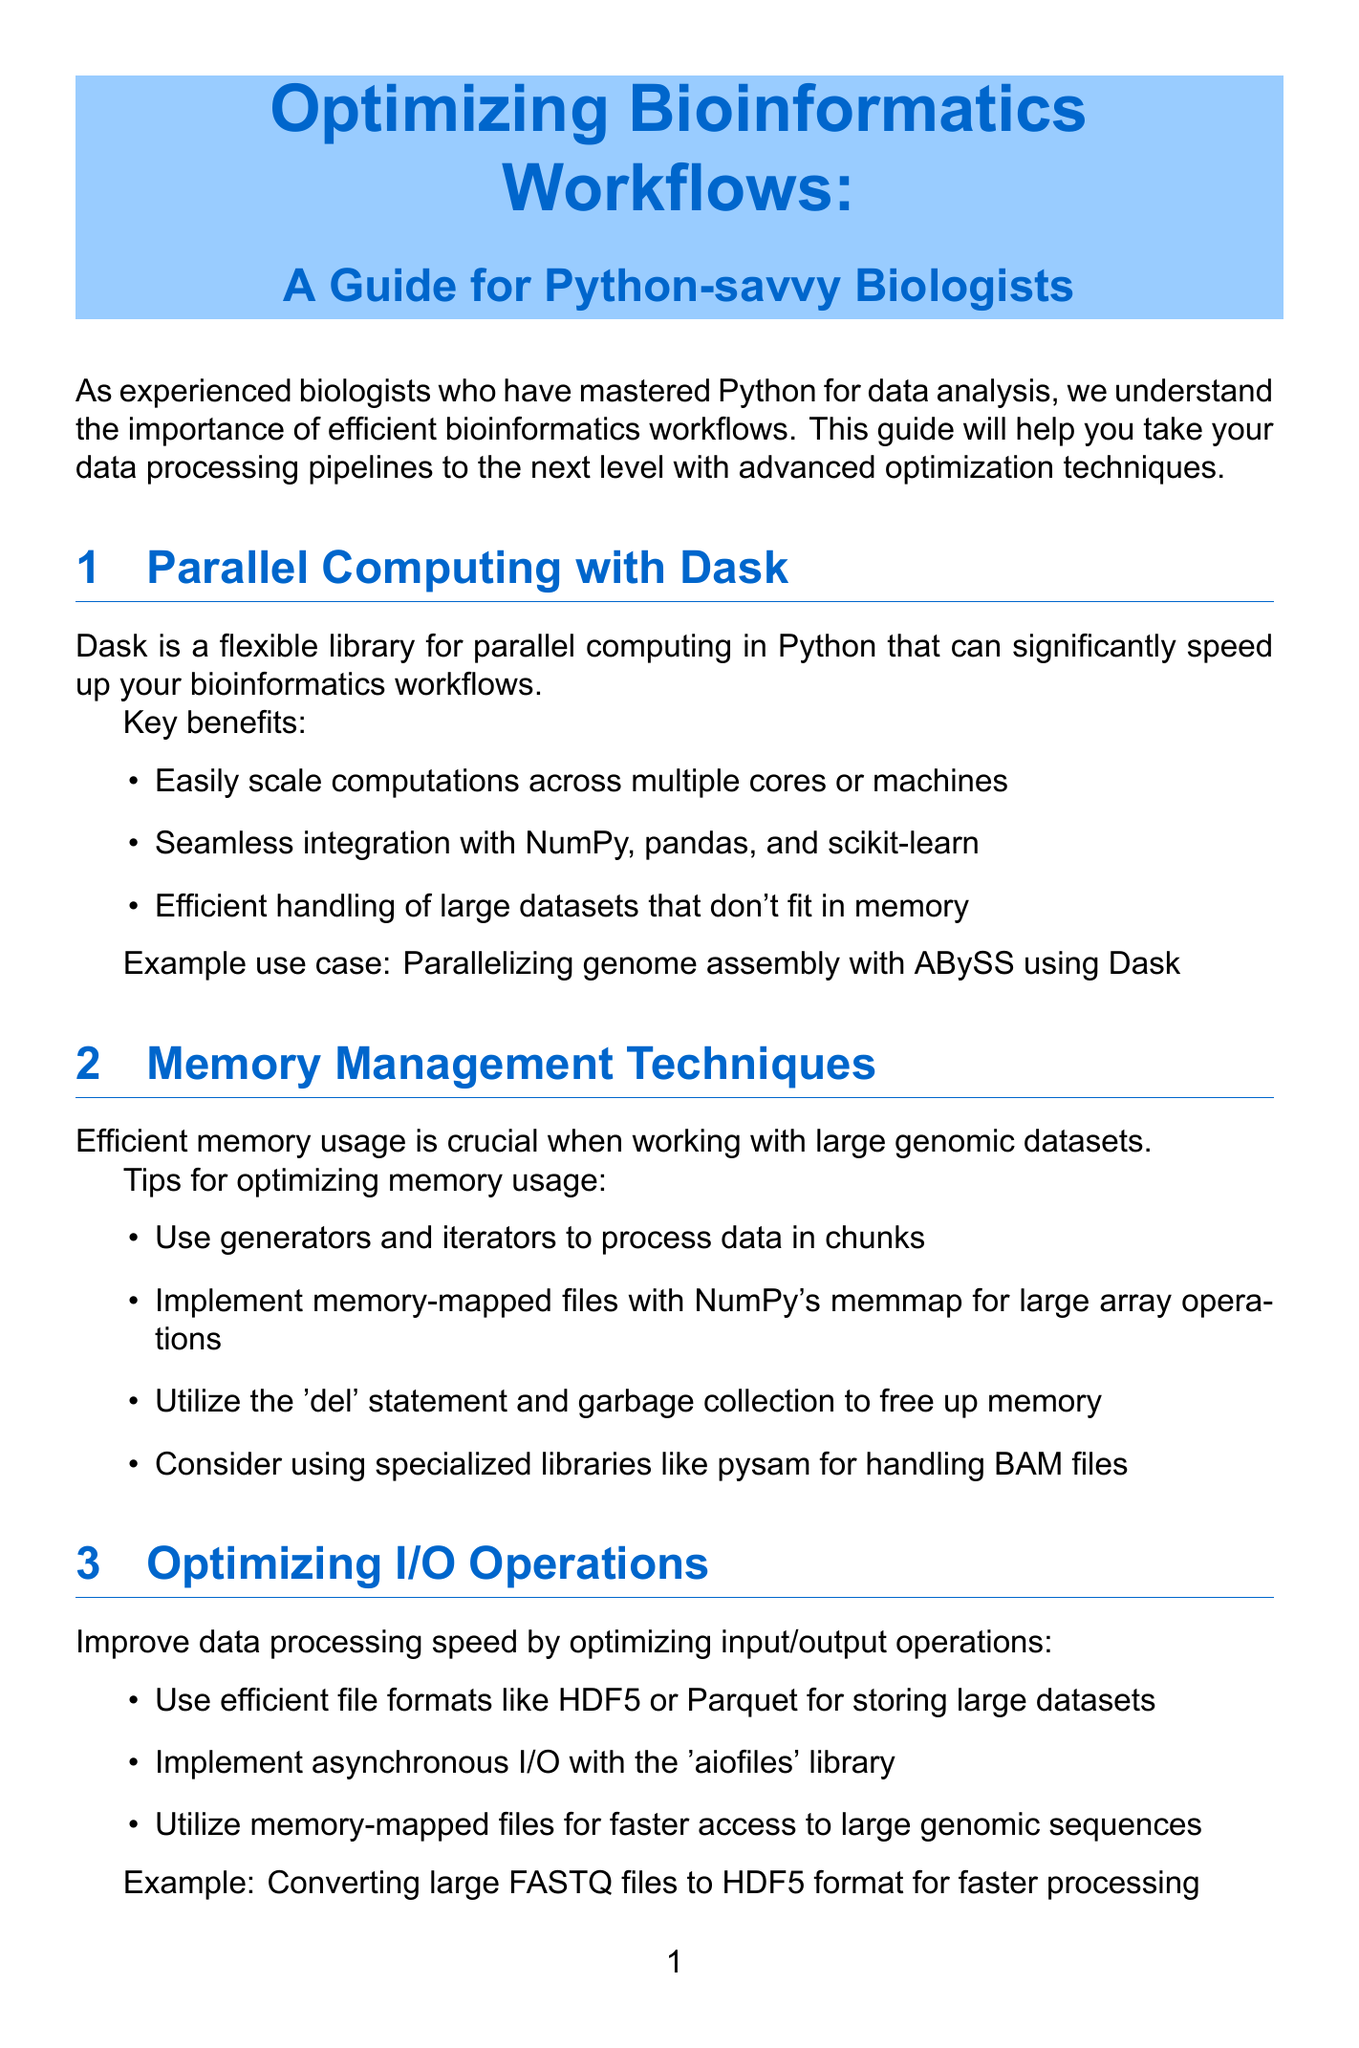What is the title of the newsletter? The title provides the main subject of the newsletter and is stated clearly at the beginning of the document.
Answer: Optimizing Bioinformatics Workflows: A Guide for Python-savvy Biologists What library is recommended for parallel computing? The document mentions a specific library suited for parallel computing tasks, emphasizing its advantages.
Answer: Dask What file formats are suggested for storing large datasets? The document lists efficient file formats that enhance data processing speeds as part of optimizing I/O operations.
Answer: HDF5 or Parquet Which technique is suggested for optimizing memory usage? The document describes specific approaches to manage memory efficiently, particularly when handling large genomic datasets.
Answer: Use generators and iterators What profiling tool can be used to analyze time-consuming functions? The document mentions tools for profiling to identify bottlenecks in bioinformatics pipelines, highlighting a specific one for functions.
Answer: line_profiler How can you streamline complex bioinformatics pipelines? The document suggests specific systems for managing workflows to make the processes smoother and more efficient.
Answer: Implement Snakemake What is a key benefit of using Dask? The document outlines several advantages of Dask, helping the reader understand its primary features.
Answer: Easily scale computations across multiple cores or machines Which library is mentioned for handling BAM files? The document provides advice on memory management and mentions libraries tailored for specific file types.
Answer: pysam 